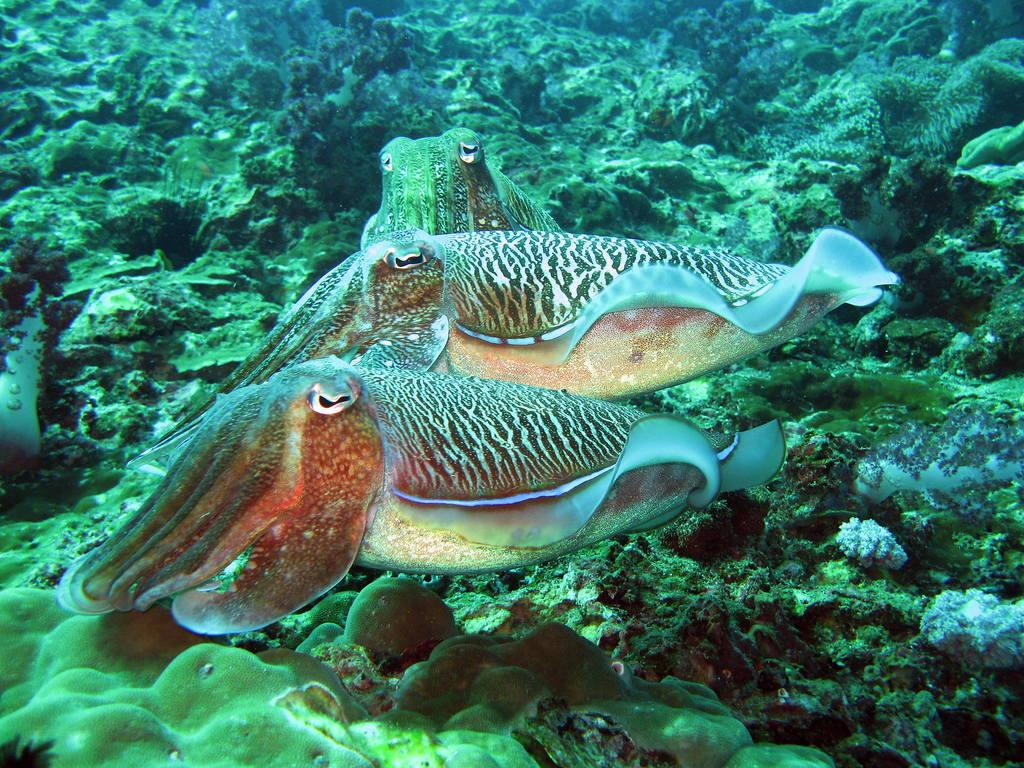What type of animals can be seen in the image? There are fishes in the image. What other objects or features can be seen in the image? There are corals in the image. What type of soda is being served in the image? There is no soda present in the image; it features fishes and corals. What type of skin condition can be seen on the fishes in the image? There is no skin condition visible on the fishes in the image, as it is an underwater scene with fishes and corals. 